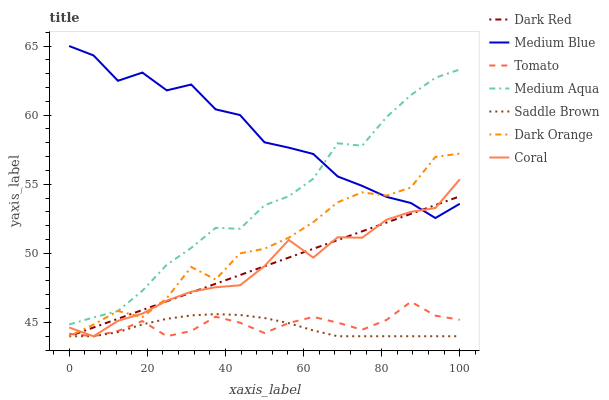Does Saddle Brown have the minimum area under the curve?
Answer yes or no. Yes. Does Medium Blue have the maximum area under the curve?
Answer yes or no. Yes. Does Dark Orange have the minimum area under the curve?
Answer yes or no. No. Does Dark Orange have the maximum area under the curve?
Answer yes or no. No. Is Dark Red the smoothest?
Answer yes or no. Yes. Is Medium Blue the roughest?
Answer yes or no. Yes. Is Dark Orange the smoothest?
Answer yes or no. No. Is Dark Orange the roughest?
Answer yes or no. No. Does Tomato have the lowest value?
Answer yes or no. Yes. Does Medium Blue have the lowest value?
Answer yes or no. No. Does Medium Blue have the highest value?
Answer yes or no. Yes. Does Dark Orange have the highest value?
Answer yes or no. No. Is Tomato less than Medium Aqua?
Answer yes or no. Yes. Is Medium Aqua greater than Coral?
Answer yes or no. Yes. Does Medium Blue intersect Dark Orange?
Answer yes or no. Yes. Is Medium Blue less than Dark Orange?
Answer yes or no. No. Is Medium Blue greater than Dark Orange?
Answer yes or no. No. Does Tomato intersect Medium Aqua?
Answer yes or no. No. 